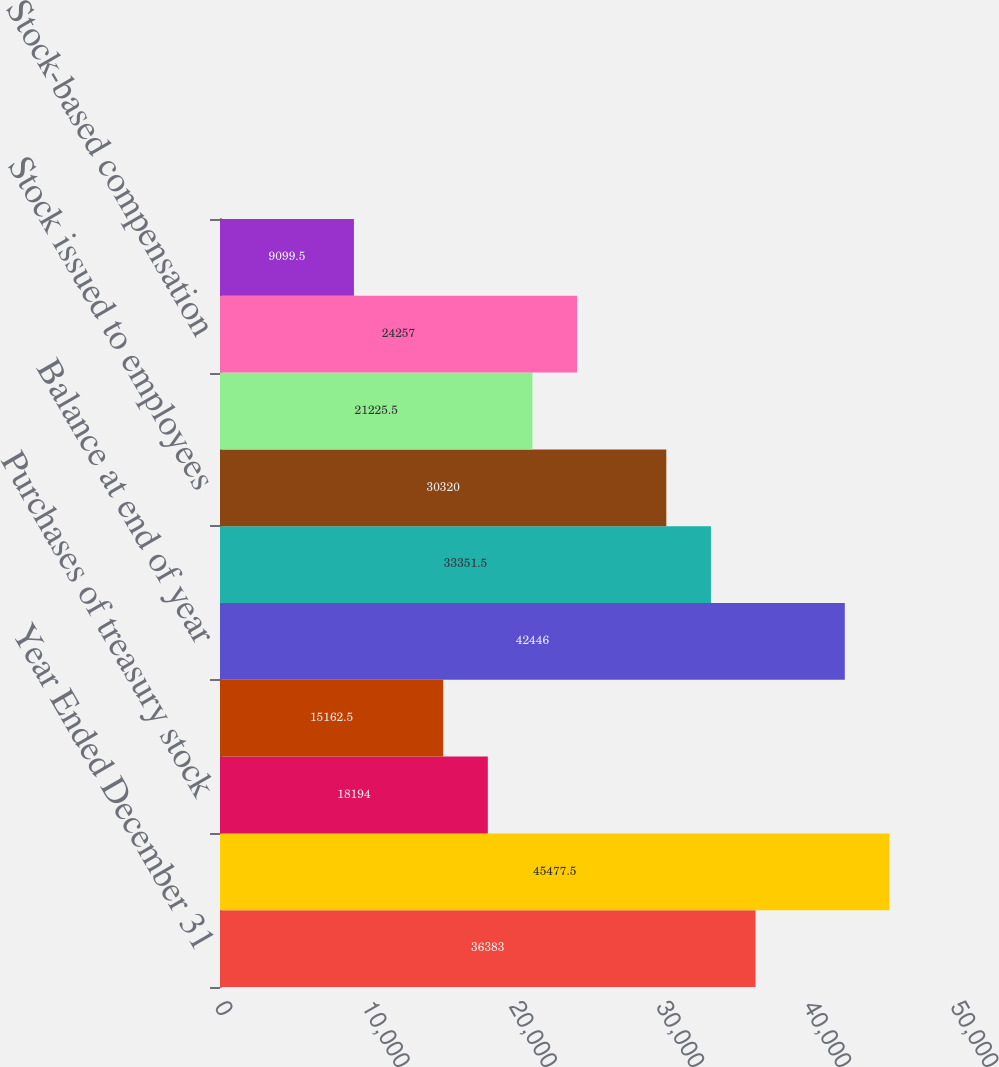Convert chart. <chart><loc_0><loc_0><loc_500><loc_500><bar_chart><fcel>Year Ended December 31<fcel>Balance at beginning of year<fcel>Purchases of treasury stock<fcel>Treasury stock issued to<fcel>Balance at end of year<fcel>COMMON STOCK<fcel>Stock issued to employees<fcel>Tax benefit (charge) from<fcel>Stock-based compensation<fcel>Other activities<nl><fcel>36383<fcel>45477.5<fcel>18194<fcel>15162.5<fcel>42446<fcel>33351.5<fcel>30320<fcel>21225.5<fcel>24257<fcel>9099.5<nl></chart> 